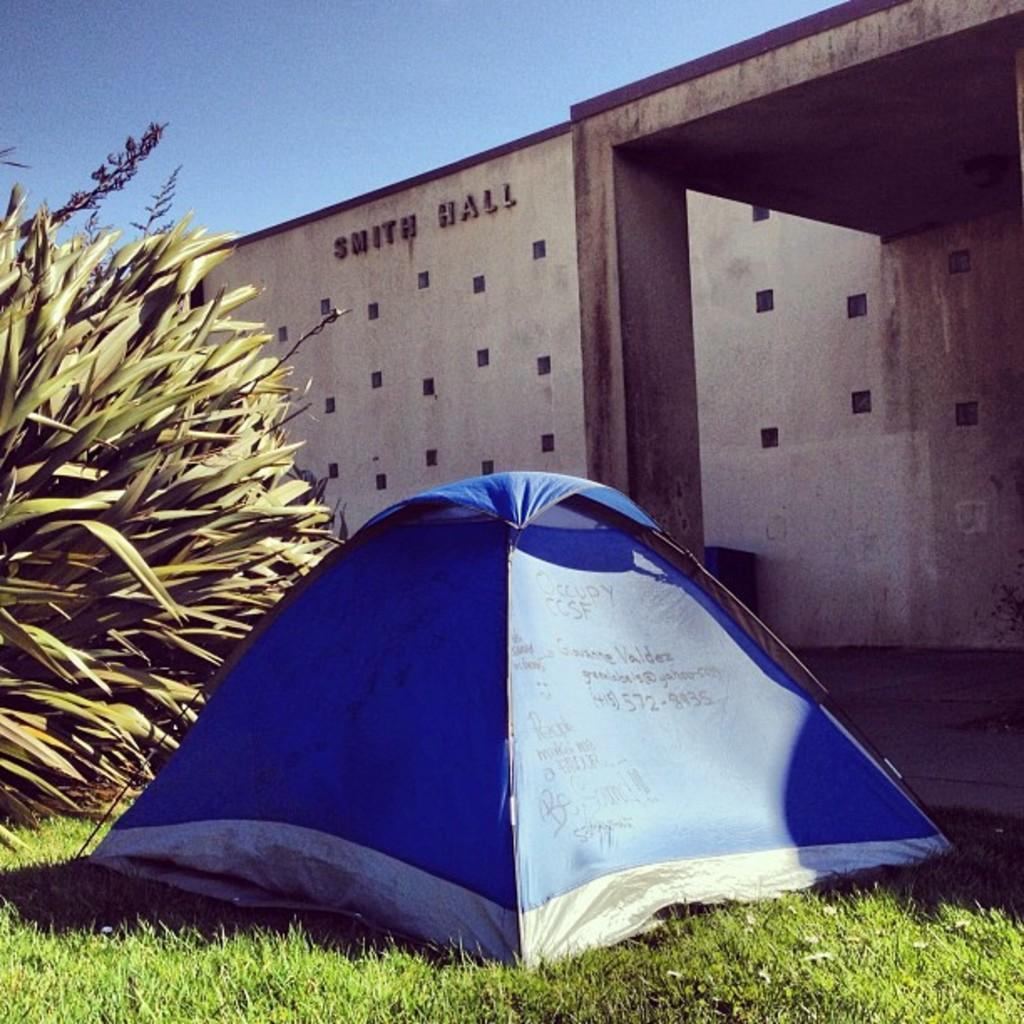How would you summarize this image in a sentence or two? In this image we can see a tent with text on it is placed on ground. To the left side of the image we can see a tree. In the background ,we can see a building with pillar and the sky. 